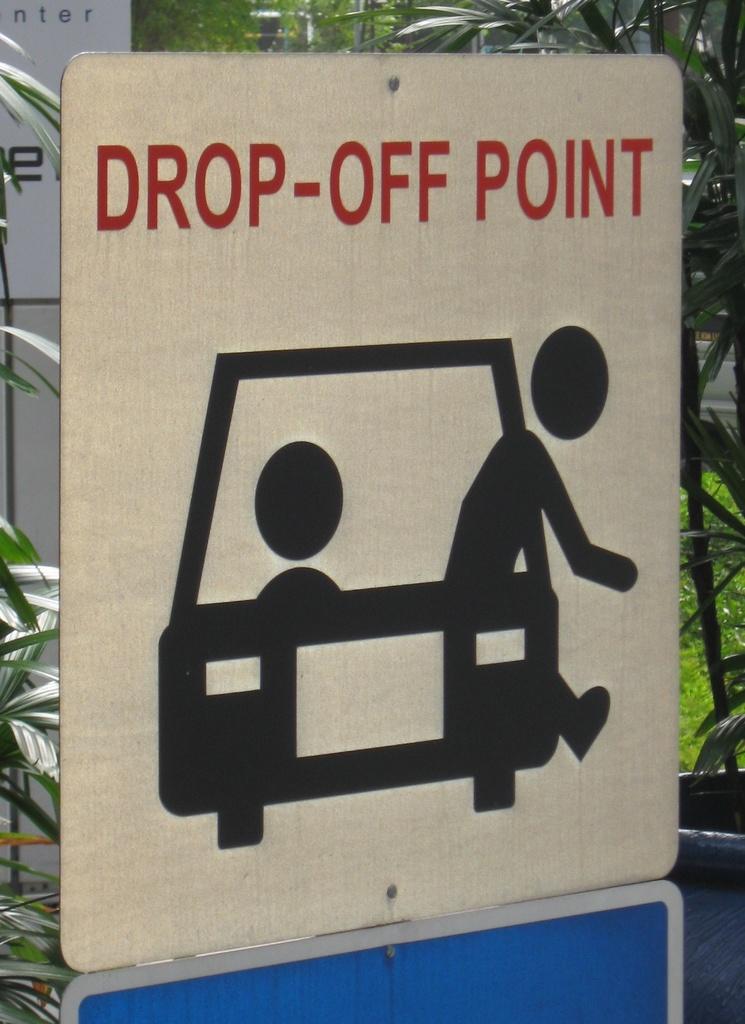What kind of point is on the sign?
Your answer should be very brief. Drop-off. What are the 4 small letters in the top left of the photo?
Your answer should be very brief. Nter. 